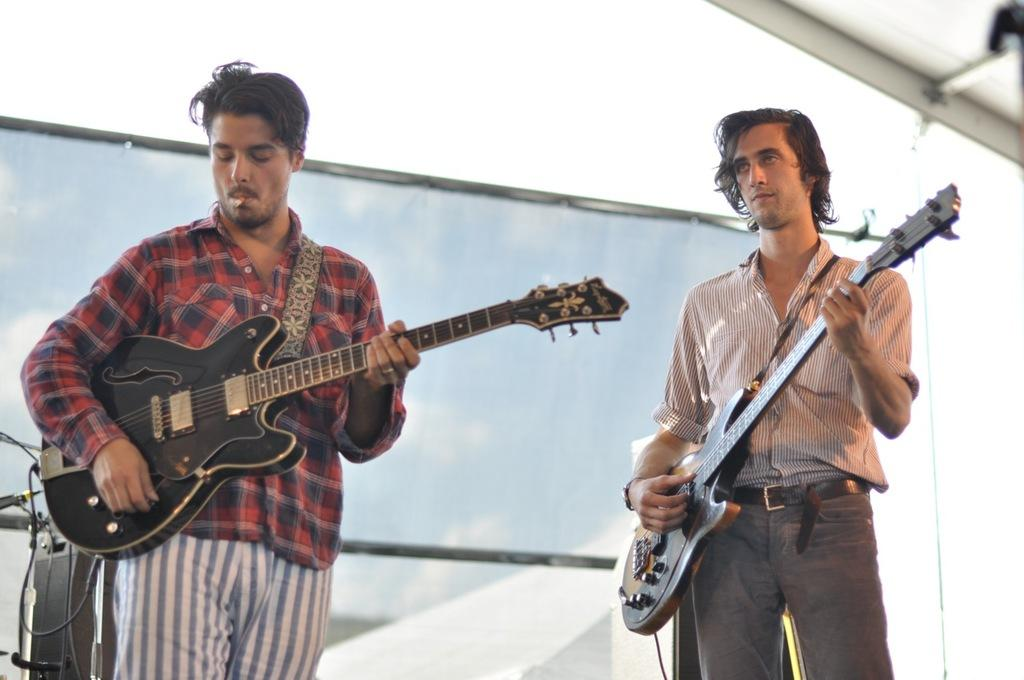How many people are in the image? There are two people in the image. What are the two people doing in the image? The two people are playing guitar. How are the guitars being held by the people? The guitars are held in their hands. What can be seen in the background of the image? There is a microphone and other musical items visible in the background. What type of kite can be seen flying in the field in the image? There is no kite or field present in the image; it features two people playing guitar with a microphone and other musical items in the background. 